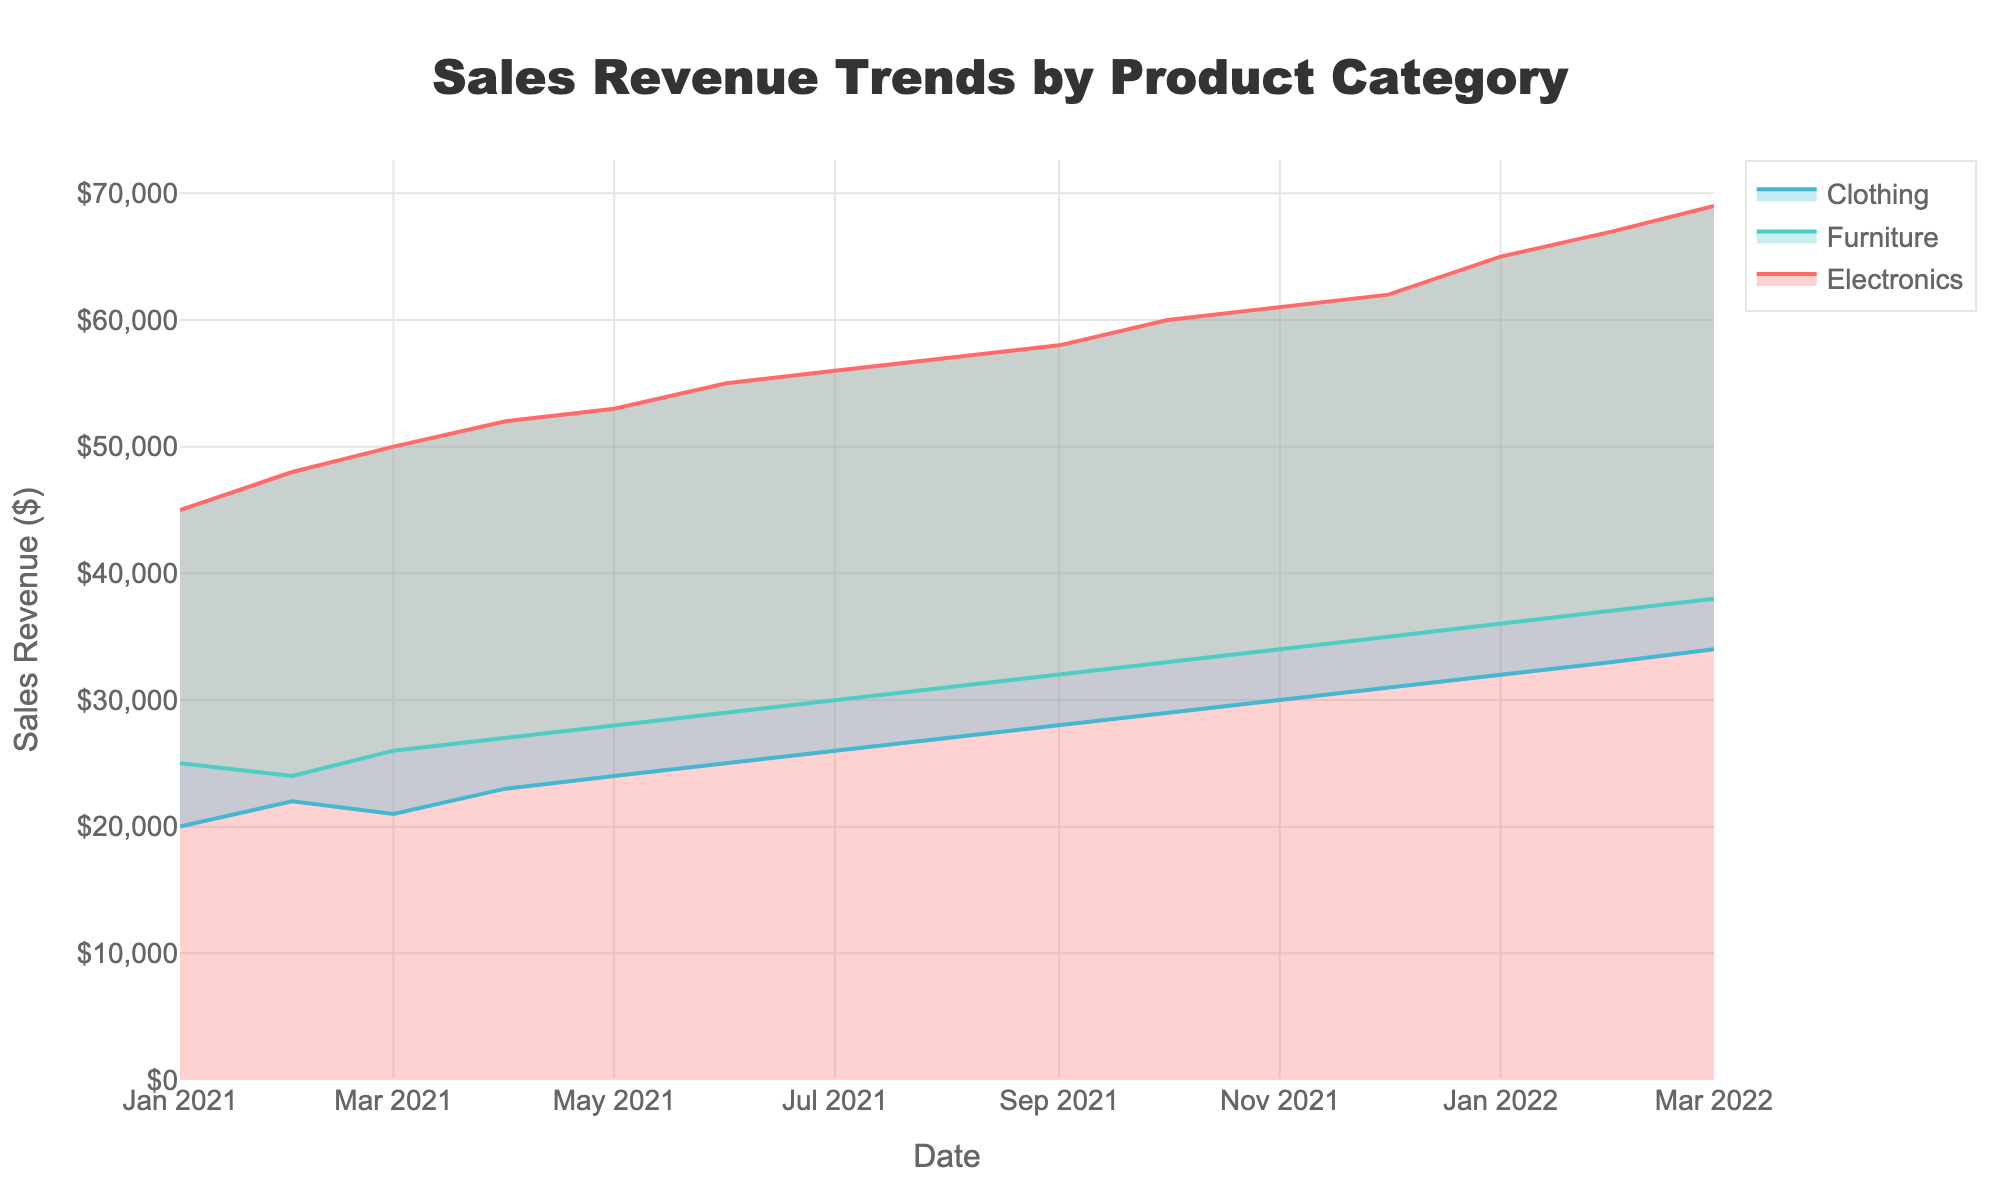what is the title of the chart? The title of the chart is displayed at the top center of the figure. In this case, it reads, "Sales Revenue Trends by Product Category."
Answer: Sales Revenue Trends by Product Category How does the sales revenue for electronics change from January 2021 to March 2022? Referencing the electronic sales line, it starts around $45,000 in January 2021 and steadily increases each month, reaching approximately $69,000 by March 2022.
Answer: It consistently increases Which product category had the highest sales revenue by the end of March 2022? The last point on the x-axis (March 2022) shows that Electronics had the sales revenue at $69,000, which is higher than Furniture and Clothing.
Answer: Electronics What is the difference between the sales revenues of Furniture and Clothing in December 2021? In December 2021, Furniture had $35,000 in sales revenue and Clothing had $31,000. Subtracting these gives $35,000 - $31,000 = $4,000.
Answer: $4,000 How does the sales revenue trend for Clothing compare to Electronics over the displayed period? Clothing shows a steady and gradual increase from $20,000 to $34,000 by March 2022. In comparison, Electronics shows a more rapid growth from $45,000 to $69,000.
Answer: Clothing increases steadily; Electronics increases rapidly What is the average sales revenue for Furniture from January 2021 to March 2022? The sales revenues for Furniture are: 25000, 24000, 26000, 27000, 28000, 29000, 30000, 31000, 32000, 33000, 34000, 35000, 36000, 37000, 38000. The sum is 234000, and the number of months is 15. Thus, the average is 234000/15 = 15600.
Answer: $31,200 Which month shows the largest month-over-month increase in sales revenue for all categories? Comparing month-over-month changes visually, Electronics shows the largest increase of $3,000 from January to February 2022, while Furniture and Clothing's changes are consistent and smaller in magnitude.
Answer: February 2022 for Electronics By how much did Clothing's sales revenue increase from January 2021 to March 2022? Initially, Clothing had $20,000 in January 2021 and ended with $34,000 in March 2022. The increase is $34,000 - $20,000 = $14,000.
Answer: $14,000 What patterns or trends in Electronics sales can help inform marketing strategies? Electronics shows a steady upward trend, indicating increasing demand. This consistent growth might suggest investing more in electronics marketing and product offerings to capitalize on the growing market.
Answer: Consistent growth; increasing demand 